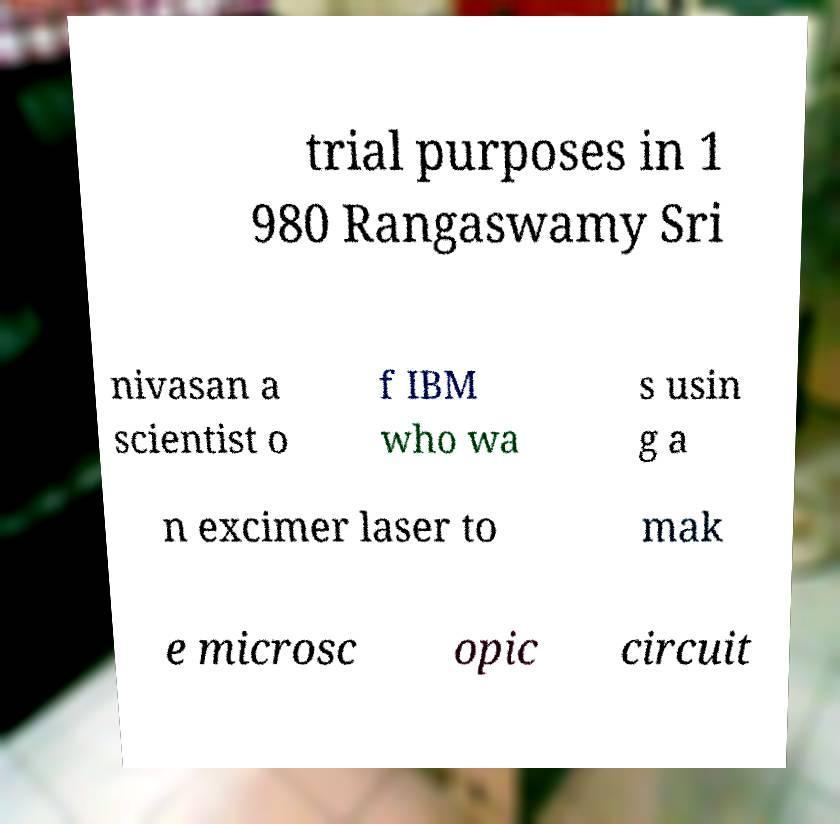Can you accurately transcribe the text from the provided image for me? trial purposes in 1 980 Rangaswamy Sri nivasan a scientist o f IBM who wa s usin g a n excimer laser to mak e microsc opic circuit 